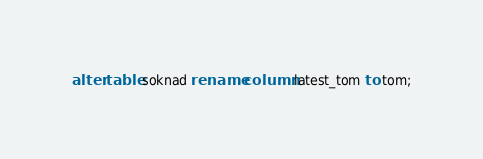<code> <loc_0><loc_0><loc_500><loc_500><_SQL_>alter table soknad rename column latest_tom to tom;
</code> 